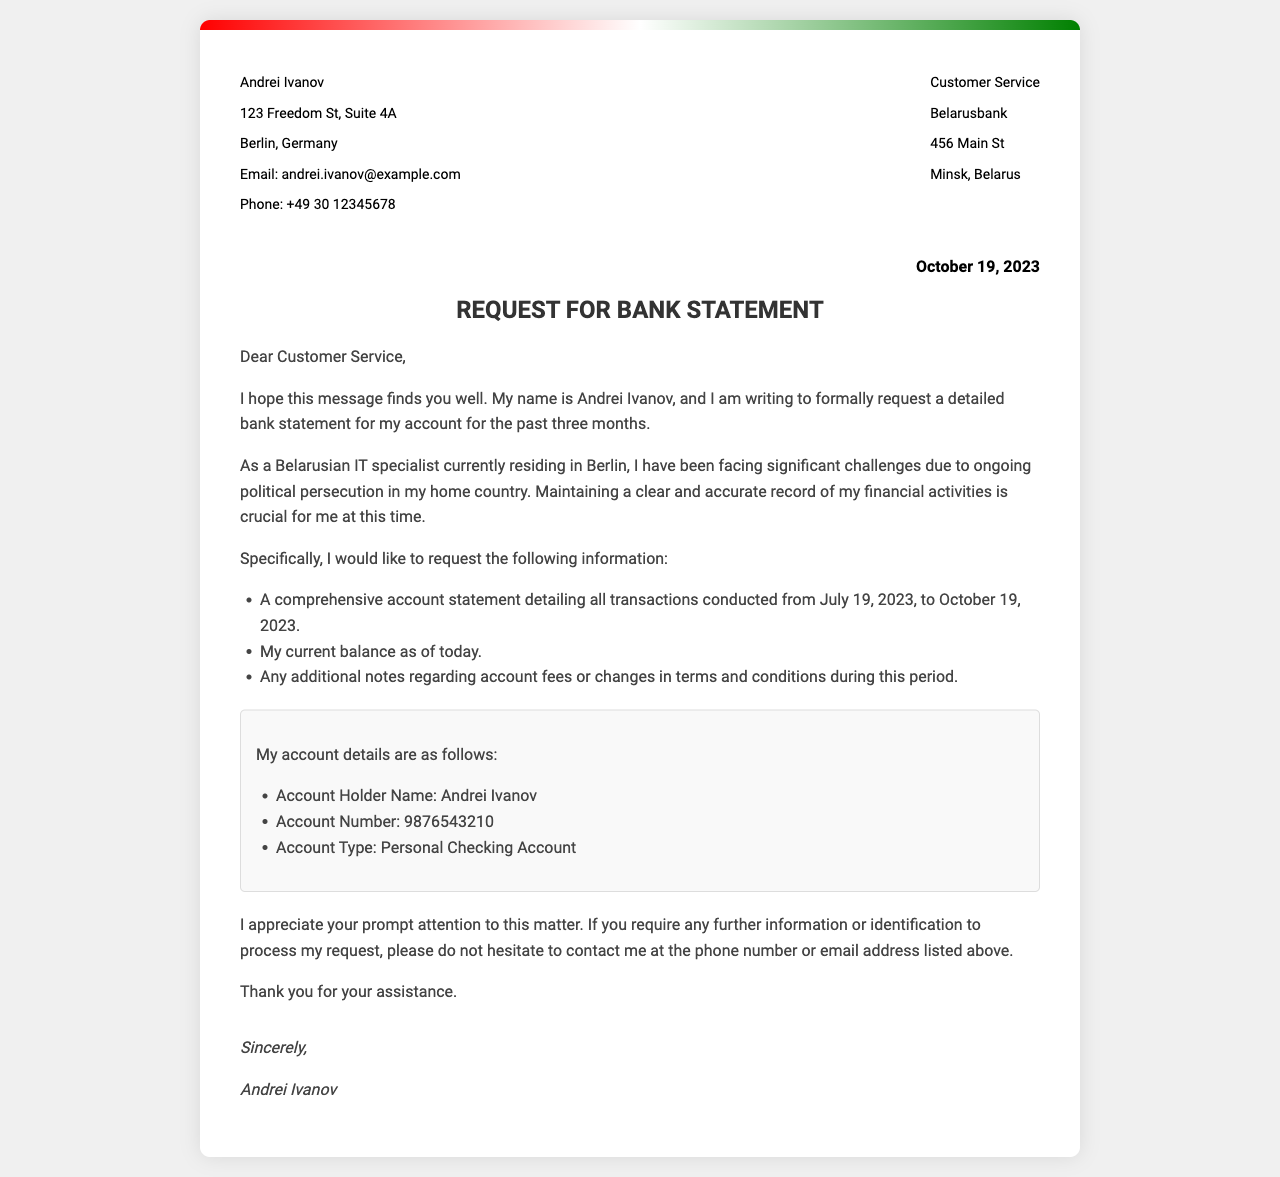What is the date of the letter? The date of the letter is specifically mentioned in the document.
Answer: October 19, 2023 Who is the account holder? The account holder's name is provided in the document header.
Answer: Andrei Ivanov What is the account number? The account number is clearly stated in the section detailing account information.
Answer: 9876543210 What is being requested in the letter? The letter explicitly outlines the request being made.
Answer: Bank statement For which period is the bank statement requested? The document specifies the time frame for the requested statement.
Answer: July 19, 2023, to October 19, 2023 Where is Andrei Ivanov currently residing? The request mentions Andrei Ivanov's current city and country.
Answer: Berlin, Germany What type of account is mentioned in the letter? The document categorizes the account type.
Answer: Personal Checking Account What does Andrei Ivanov express about his situation? Andrei Ivanov describes his circumstances in relation to political issues.
Answer: Political persecution What is the task requested of Customer Service? The letter clearly directs Customer Service in a specific manner.
Answer: Provide a comprehensive account statement 